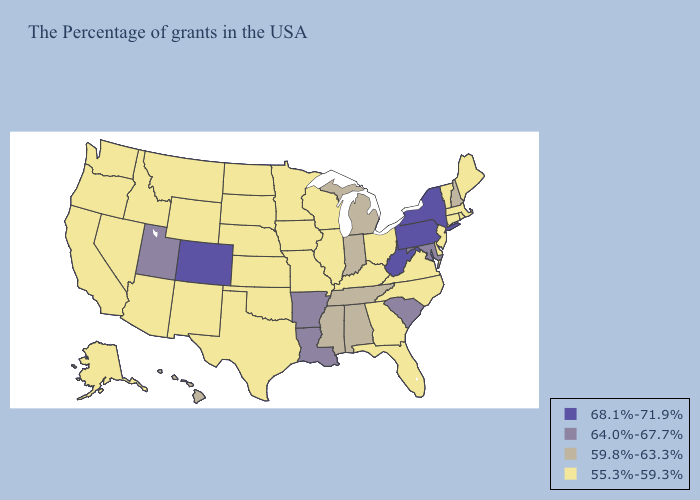Name the states that have a value in the range 55.3%-59.3%?
Write a very short answer. Maine, Massachusetts, Rhode Island, Vermont, Connecticut, New Jersey, Delaware, Virginia, North Carolina, Ohio, Florida, Georgia, Kentucky, Wisconsin, Illinois, Missouri, Minnesota, Iowa, Kansas, Nebraska, Oklahoma, Texas, South Dakota, North Dakota, Wyoming, New Mexico, Montana, Arizona, Idaho, Nevada, California, Washington, Oregon, Alaska. Name the states that have a value in the range 59.8%-63.3%?
Write a very short answer. New Hampshire, Michigan, Indiana, Alabama, Tennessee, Mississippi, Hawaii. Does Ohio have the highest value in the USA?
Give a very brief answer. No. What is the highest value in the USA?
Be succinct. 68.1%-71.9%. Does New York have the highest value in the USA?
Concise answer only. Yes. Which states have the lowest value in the USA?
Write a very short answer. Maine, Massachusetts, Rhode Island, Vermont, Connecticut, New Jersey, Delaware, Virginia, North Carolina, Ohio, Florida, Georgia, Kentucky, Wisconsin, Illinois, Missouri, Minnesota, Iowa, Kansas, Nebraska, Oklahoma, Texas, South Dakota, North Dakota, Wyoming, New Mexico, Montana, Arizona, Idaho, Nevada, California, Washington, Oregon, Alaska. Which states hav the highest value in the MidWest?
Write a very short answer. Michigan, Indiana. What is the value of Virginia?
Answer briefly. 55.3%-59.3%. Name the states that have a value in the range 64.0%-67.7%?
Give a very brief answer. Maryland, South Carolina, Louisiana, Arkansas, Utah. What is the value of Illinois?
Give a very brief answer. 55.3%-59.3%. What is the lowest value in the MidWest?
Give a very brief answer. 55.3%-59.3%. Name the states that have a value in the range 64.0%-67.7%?
Keep it brief. Maryland, South Carolina, Louisiana, Arkansas, Utah. Name the states that have a value in the range 68.1%-71.9%?
Give a very brief answer. New York, Pennsylvania, West Virginia, Colorado. What is the value of Montana?
Be succinct. 55.3%-59.3%. Which states have the highest value in the USA?
Short answer required. New York, Pennsylvania, West Virginia, Colorado. 